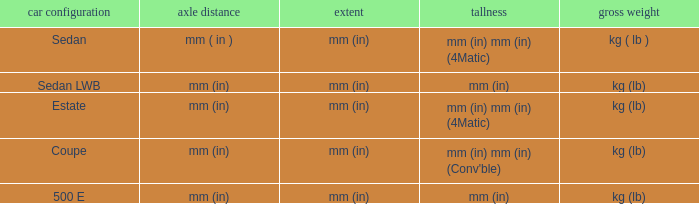What's the length of the model with 500 E body style? Mm (in). 